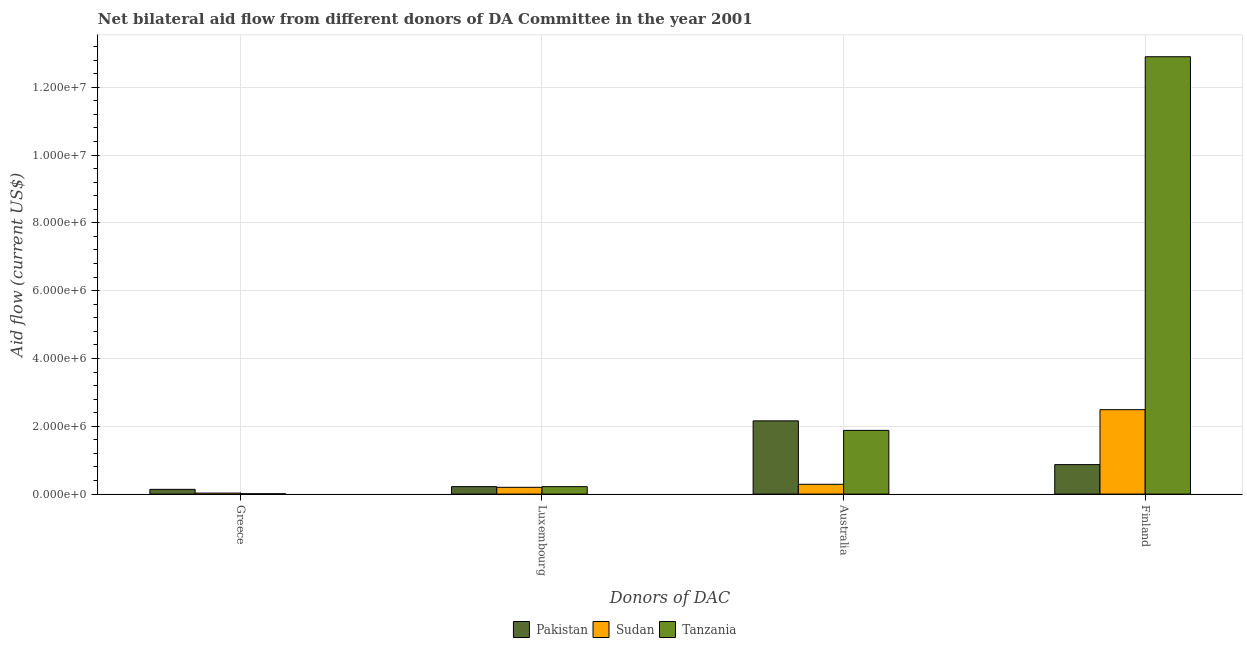How many different coloured bars are there?
Offer a very short reply. 3. How many groups of bars are there?
Provide a succinct answer. 4. How many bars are there on the 3rd tick from the left?
Give a very brief answer. 3. How many bars are there on the 2nd tick from the right?
Your answer should be very brief. 3. What is the label of the 3rd group of bars from the left?
Your answer should be very brief. Australia. What is the amount of aid given by greece in Tanzania?
Provide a succinct answer. 10000. Across all countries, what is the maximum amount of aid given by australia?
Ensure brevity in your answer.  2.16e+06. Across all countries, what is the minimum amount of aid given by greece?
Give a very brief answer. 10000. In which country was the amount of aid given by finland maximum?
Keep it short and to the point. Tanzania. In which country was the amount of aid given by finland minimum?
Provide a succinct answer. Pakistan. What is the total amount of aid given by greece in the graph?
Your response must be concise. 1.80e+05. What is the difference between the amount of aid given by finland in Pakistan and that in Sudan?
Ensure brevity in your answer.  -1.62e+06. What is the difference between the amount of aid given by greece in Pakistan and the amount of aid given by luxembourg in Tanzania?
Keep it short and to the point. -8.00e+04. What is the average amount of aid given by australia per country?
Your answer should be compact. 1.44e+06. What is the difference between the amount of aid given by greece and amount of aid given by australia in Pakistan?
Offer a very short reply. -2.02e+06. In how many countries, is the amount of aid given by australia greater than 6400000 US$?
Provide a short and direct response. 0. What is the ratio of the amount of aid given by greece in Sudan to that in Pakistan?
Make the answer very short. 0.21. Is the amount of aid given by greece in Sudan less than that in Pakistan?
Make the answer very short. Yes. Is the difference between the amount of aid given by greece in Tanzania and Sudan greater than the difference between the amount of aid given by finland in Tanzania and Sudan?
Make the answer very short. No. What is the difference between the highest and the second highest amount of aid given by greece?
Your answer should be very brief. 1.10e+05. What is the difference between the highest and the lowest amount of aid given by australia?
Your answer should be compact. 1.87e+06. Is the sum of the amount of aid given by luxembourg in Pakistan and Tanzania greater than the maximum amount of aid given by australia across all countries?
Your response must be concise. No. Is it the case that in every country, the sum of the amount of aid given by australia and amount of aid given by luxembourg is greater than the sum of amount of aid given by finland and amount of aid given by greece?
Give a very brief answer. No. What does the 3rd bar from the left in Finland represents?
Give a very brief answer. Tanzania. What does the 1st bar from the right in Greece represents?
Your answer should be very brief. Tanzania. Is it the case that in every country, the sum of the amount of aid given by greece and amount of aid given by luxembourg is greater than the amount of aid given by australia?
Keep it short and to the point. No. How many bars are there?
Provide a succinct answer. 12. What is the difference between two consecutive major ticks on the Y-axis?
Offer a very short reply. 2.00e+06. Does the graph contain grids?
Ensure brevity in your answer.  Yes. Where does the legend appear in the graph?
Your answer should be very brief. Bottom center. How are the legend labels stacked?
Give a very brief answer. Horizontal. What is the title of the graph?
Offer a terse response. Net bilateral aid flow from different donors of DA Committee in the year 2001. Does "Zambia" appear as one of the legend labels in the graph?
Provide a short and direct response. No. What is the label or title of the X-axis?
Provide a succinct answer. Donors of DAC. What is the Aid flow (current US$) of Sudan in Greece?
Offer a terse response. 3.00e+04. What is the Aid flow (current US$) in Tanzania in Luxembourg?
Offer a terse response. 2.20e+05. What is the Aid flow (current US$) of Pakistan in Australia?
Your answer should be compact. 2.16e+06. What is the Aid flow (current US$) in Sudan in Australia?
Ensure brevity in your answer.  2.90e+05. What is the Aid flow (current US$) in Tanzania in Australia?
Your response must be concise. 1.88e+06. What is the Aid flow (current US$) of Pakistan in Finland?
Provide a short and direct response. 8.70e+05. What is the Aid flow (current US$) in Sudan in Finland?
Your answer should be compact. 2.49e+06. What is the Aid flow (current US$) of Tanzania in Finland?
Give a very brief answer. 1.29e+07. Across all Donors of DAC, what is the maximum Aid flow (current US$) in Pakistan?
Offer a very short reply. 2.16e+06. Across all Donors of DAC, what is the maximum Aid flow (current US$) of Sudan?
Your response must be concise. 2.49e+06. Across all Donors of DAC, what is the maximum Aid flow (current US$) of Tanzania?
Ensure brevity in your answer.  1.29e+07. Across all Donors of DAC, what is the minimum Aid flow (current US$) of Sudan?
Your answer should be very brief. 3.00e+04. What is the total Aid flow (current US$) of Pakistan in the graph?
Give a very brief answer. 3.39e+06. What is the total Aid flow (current US$) in Sudan in the graph?
Offer a very short reply. 3.01e+06. What is the total Aid flow (current US$) of Tanzania in the graph?
Your answer should be very brief. 1.50e+07. What is the difference between the Aid flow (current US$) of Pakistan in Greece and that in Luxembourg?
Your response must be concise. -8.00e+04. What is the difference between the Aid flow (current US$) in Tanzania in Greece and that in Luxembourg?
Provide a succinct answer. -2.10e+05. What is the difference between the Aid flow (current US$) of Pakistan in Greece and that in Australia?
Your answer should be compact. -2.02e+06. What is the difference between the Aid flow (current US$) of Tanzania in Greece and that in Australia?
Your answer should be compact. -1.87e+06. What is the difference between the Aid flow (current US$) of Pakistan in Greece and that in Finland?
Give a very brief answer. -7.30e+05. What is the difference between the Aid flow (current US$) of Sudan in Greece and that in Finland?
Offer a very short reply. -2.46e+06. What is the difference between the Aid flow (current US$) in Tanzania in Greece and that in Finland?
Make the answer very short. -1.29e+07. What is the difference between the Aid flow (current US$) of Pakistan in Luxembourg and that in Australia?
Offer a very short reply. -1.94e+06. What is the difference between the Aid flow (current US$) in Sudan in Luxembourg and that in Australia?
Offer a very short reply. -9.00e+04. What is the difference between the Aid flow (current US$) in Tanzania in Luxembourg and that in Australia?
Make the answer very short. -1.66e+06. What is the difference between the Aid flow (current US$) of Pakistan in Luxembourg and that in Finland?
Your answer should be very brief. -6.50e+05. What is the difference between the Aid flow (current US$) of Sudan in Luxembourg and that in Finland?
Your answer should be compact. -2.29e+06. What is the difference between the Aid flow (current US$) of Tanzania in Luxembourg and that in Finland?
Offer a terse response. -1.27e+07. What is the difference between the Aid flow (current US$) of Pakistan in Australia and that in Finland?
Provide a short and direct response. 1.29e+06. What is the difference between the Aid flow (current US$) of Sudan in Australia and that in Finland?
Make the answer very short. -2.20e+06. What is the difference between the Aid flow (current US$) in Tanzania in Australia and that in Finland?
Make the answer very short. -1.10e+07. What is the difference between the Aid flow (current US$) of Sudan in Greece and the Aid flow (current US$) of Tanzania in Luxembourg?
Offer a terse response. -1.90e+05. What is the difference between the Aid flow (current US$) of Pakistan in Greece and the Aid flow (current US$) of Sudan in Australia?
Provide a short and direct response. -1.50e+05. What is the difference between the Aid flow (current US$) in Pakistan in Greece and the Aid flow (current US$) in Tanzania in Australia?
Make the answer very short. -1.74e+06. What is the difference between the Aid flow (current US$) of Sudan in Greece and the Aid flow (current US$) of Tanzania in Australia?
Give a very brief answer. -1.85e+06. What is the difference between the Aid flow (current US$) in Pakistan in Greece and the Aid flow (current US$) in Sudan in Finland?
Offer a terse response. -2.35e+06. What is the difference between the Aid flow (current US$) of Pakistan in Greece and the Aid flow (current US$) of Tanzania in Finland?
Keep it short and to the point. -1.28e+07. What is the difference between the Aid flow (current US$) in Sudan in Greece and the Aid flow (current US$) in Tanzania in Finland?
Your answer should be very brief. -1.29e+07. What is the difference between the Aid flow (current US$) in Pakistan in Luxembourg and the Aid flow (current US$) in Tanzania in Australia?
Ensure brevity in your answer.  -1.66e+06. What is the difference between the Aid flow (current US$) in Sudan in Luxembourg and the Aid flow (current US$) in Tanzania in Australia?
Make the answer very short. -1.68e+06. What is the difference between the Aid flow (current US$) of Pakistan in Luxembourg and the Aid flow (current US$) of Sudan in Finland?
Your response must be concise. -2.27e+06. What is the difference between the Aid flow (current US$) of Pakistan in Luxembourg and the Aid flow (current US$) of Tanzania in Finland?
Ensure brevity in your answer.  -1.27e+07. What is the difference between the Aid flow (current US$) of Sudan in Luxembourg and the Aid flow (current US$) of Tanzania in Finland?
Ensure brevity in your answer.  -1.27e+07. What is the difference between the Aid flow (current US$) of Pakistan in Australia and the Aid flow (current US$) of Sudan in Finland?
Offer a terse response. -3.30e+05. What is the difference between the Aid flow (current US$) in Pakistan in Australia and the Aid flow (current US$) in Tanzania in Finland?
Give a very brief answer. -1.07e+07. What is the difference between the Aid flow (current US$) of Sudan in Australia and the Aid flow (current US$) of Tanzania in Finland?
Offer a terse response. -1.26e+07. What is the average Aid flow (current US$) of Pakistan per Donors of DAC?
Keep it short and to the point. 8.48e+05. What is the average Aid flow (current US$) in Sudan per Donors of DAC?
Your response must be concise. 7.52e+05. What is the average Aid flow (current US$) in Tanzania per Donors of DAC?
Your answer should be very brief. 3.75e+06. What is the difference between the Aid flow (current US$) in Pakistan and Aid flow (current US$) in Sudan in Greece?
Your response must be concise. 1.10e+05. What is the difference between the Aid flow (current US$) in Sudan and Aid flow (current US$) in Tanzania in Greece?
Your answer should be very brief. 2.00e+04. What is the difference between the Aid flow (current US$) in Pakistan and Aid flow (current US$) in Sudan in Luxembourg?
Your answer should be compact. 2.00e+04. What is the difference between the Aid flow (current US$) in Pakistan and Aid flow (current US$) in Tanzania in Luxembourg?
Give a very brief answer. 0. What is the difference between the Aid flow (current US$) of Pakistan and Aid flow (current US$) of Sudan in Australia?
Offer a very short reply. 1.87e+06. What is the difference between the Aid flow (current US$) in Sudan and Aid flow (current US$) in Tanzania in Australia?
Provide a short and direct response. -1.59e+06. What is the difference between the Aid flow (current US$) in Pakistan and Aid flow (current US$) in Sudan in Finland?
Your answer should be very brief. -1.62e+06. What is the difference between the Aid flow (current US$) of Pakistan and Aid flow (current US$) of Tanzania in Finland?
Offer a terse response. -1.20e+07. What is the difference between the Aid flow (current US$) in Sudan and Aid flow (current US$) in Tanzania in Finland?
Your answer should be compact. -1.04e+07. What is the ratio of the Aid flow (current US$) of Pakistan in Greece to that in Luxembourg?
Offer a terse response. 0.64. What is the ratio of the Aid flow (current US$) in Tanzania in Greece to that in Luxembourg?
Your answer should be very brief. 0.05. What is the ratio of the Aid flow (current US$) in Pakistan in Greece to that in Australia?
Offer a very short reply. 0.06. What is the ratio of the Aid flow (current US$) of Sudan in Greece to that in Australia?
Offer a terse response. 0.1. What is the ratio of the Aid flow (current US$) in Tanzania in Greece to that in Australia?
Give a very brief answer. 0.01. What is the ratio of the Aid flow (current US$) in Pakistan in Greece to that in Finland?
Your answer should be compact. 0.16. What is the ratio of the Aid flow (current US$) in Sudan in Greece to that in Finland?
Your response must be concise. 0.01. What is the ratio of the Aid flow (current US$) in Tanzania in Greece to that in Finland?
Offer a very short reply. 0. What is the ratio of the Aid flow (current US$) of Pakistan in Luxembourg to that in Australia?
Your answer should be compact. 0.1. What is the ratio of the Aid flow (current US$) in Sudan in Luxembourg to that in Australia?
Ensure brevity in your answer.  0.69. What is the ratio of the Aid flow (current US$) in Tanzania in Luxembourg to that in Australia?
Offer a very short reply. 0.12. What is the ratio of the Aid flow (current US$) of Pakistan in Luxembourg to that in Finland?
Your answer should be compact. 0.25. What is the ratio of the Aid flow (current US$) of Sudan in Luxembourg to that in Finland?
Provide a short and direct response. 0.08. What is the ratio of the Aid flow (current US$) of Tanzania in Luxembourg to that in Finland?
Offer a very short reply. 0.02. What is the ratio of the Aid flow (current US$) of Pakistan in Australia to that in Finland?
Offer a very short reply. 2.48. What is the ratio of the Aid flow (current US$) in Sudan in Australia to that in Finland?
Your response must be concise. 0.12. What is the ratio of the Aid flow (current US$) of Tanzania in Australia to that in Finland?
Provide a succinct answer. 0.15. What is the difference between the highest and the second highest Aid flow (current US$) of Pakistan?
Your response must be concise. 1.29e+06. What is the difference between the highest and the second highest Aid flow (current US$) in Sudan?
Keep it short and to the point. 2.20e+06. What is the difference between the highest and the second highest Aid flow (current US$) in Tanzania?
Give a very brief answer. 1.10e+07. What is the difference between the highest and the lowest Aid flow (current US$) of Pakistan?
Keep it short and to the point. 2.02e+06. What is the difference between the highest and the lowest Aid flow (current US$) in Sudan?
Give a very brief answer. 2.46e+06. What is the difference between the highest and the lowest Aid flow (current US$) of Tanzania?
Offer a terse response. 1.29e+07. 